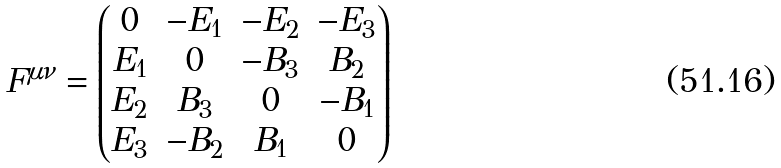<formula> <loc_0><loc_0><loc_500><loc_500>F ^ { \mu \nu } = \begin{pmatrix} 0 & - E _ { 1 } & - E _ { 2 } & - E _ { 3 } \\ E _ { 1 } & 0 & - B _ { 3 } & B _ { 2 } \\ E _ { 2 } & B _ { 3 } & 0 & - B _ { 1 } \\ E _ { 3 } & - B _ { 2 } & B _ { 1 } & 0 \end{pmatrix}</formula> 